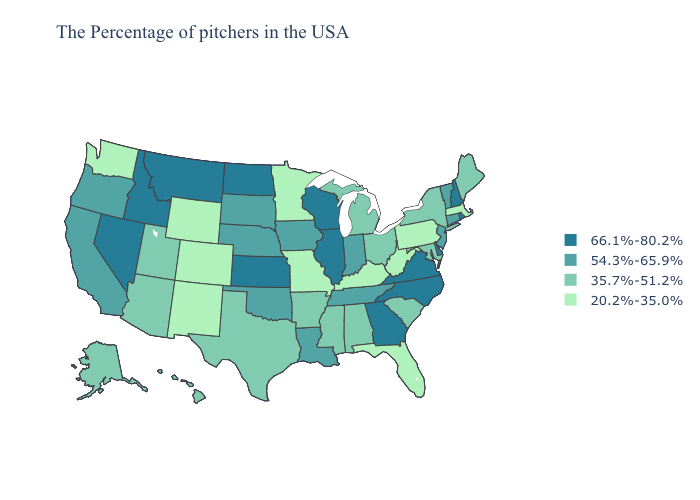Does the first symbol in the legend represent the smallest category?
Be succinct. No. Among the states that border Nebraska , which have the highest value?
Write a very short answer. Kansas. What is the highest value in the Northeast ?
Write a very short answer. 66.1%-80.2%. Name the states that have a value in the range 20.2%-35.0%?
Short answer required. Massachusetts, Pennsylvania, West Virginia, Florida, Kentucky, Missouri, Minnesota, Wyoming, Colorado, New Mexico, Washington. Which states have the highest value in the USA?
Be succinct. Rhode Island, New Hampshire, Delaware, Virginia, North Carolina, Georgia, Wisconsin, Illinois, Kansas, North Dakota, Montana, Idaho, Nevada. Does Idaho have the highest value in the USA?
Keep it brief. Yes. What is the value of Pennsylvania?
Write a very short answer. 20.2%-35.0%. What is the value of Wisconsin?
Give a very brief answer. 66.1%-80.2%. Name the states that have a value in the range 54.3%-65.9%?
Concise answer only. Vermont, Connecticut, New Jersey, Indiana, Tennessee, Louisiana, Iowa, Nebraska, Oklahoma, South Dakota, California, Oregon. Does Nevada have a higher value than Mississippi?
Quick response, please. Yes. Does Connecticut have a higher value than South Dakota?
Concise answer only. No. How many symbols are there in the legend?
Keep it brief. 4. What is the value of West Virginia?
Answer briefly. 20.2%-35.0%. Name the states that have a value in the range 66.1%-80.2%?
Quick response, please. Rhode Island, New Hampshire, Delaware, Virginia, North Carolina, Georgia, Wisconsin, Illinois, Kansas, North Dakota, Montana, Idaho, Nevada. Which states hav the highest value in the South?
Be succinct. Delaware, Virginia, North Carolina, Georgia. 